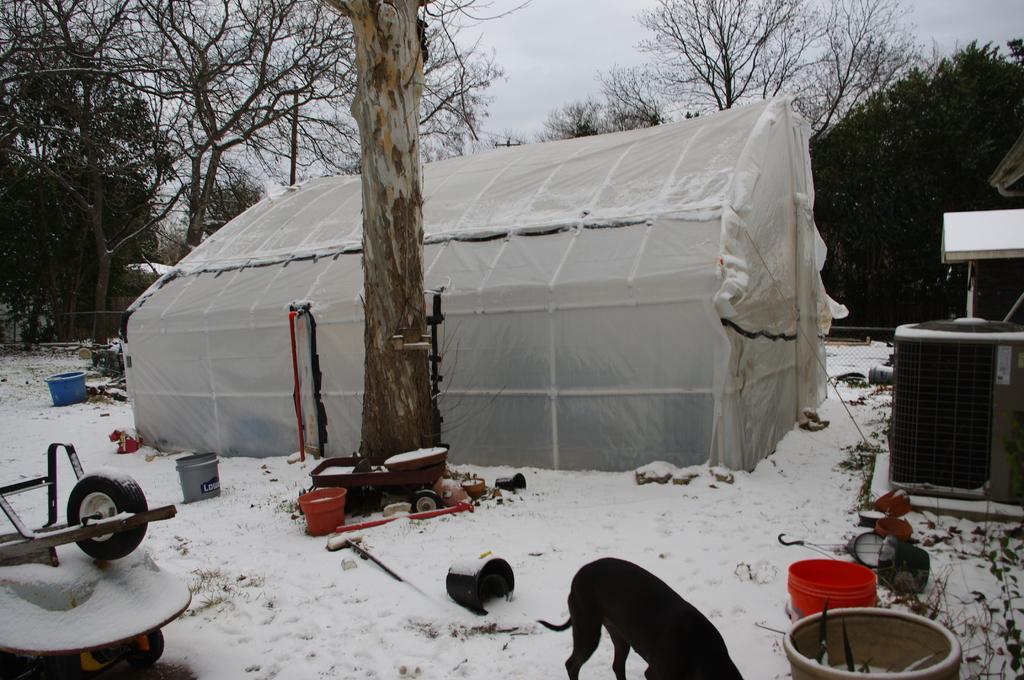In one or two sentences, can you explain what this image depicts? In this image I can see the snow on the ground, few buckets, a vehicle, an animal which is black in color, a black colored object and a white colored tent. In the background I can see few trees and the sky. 